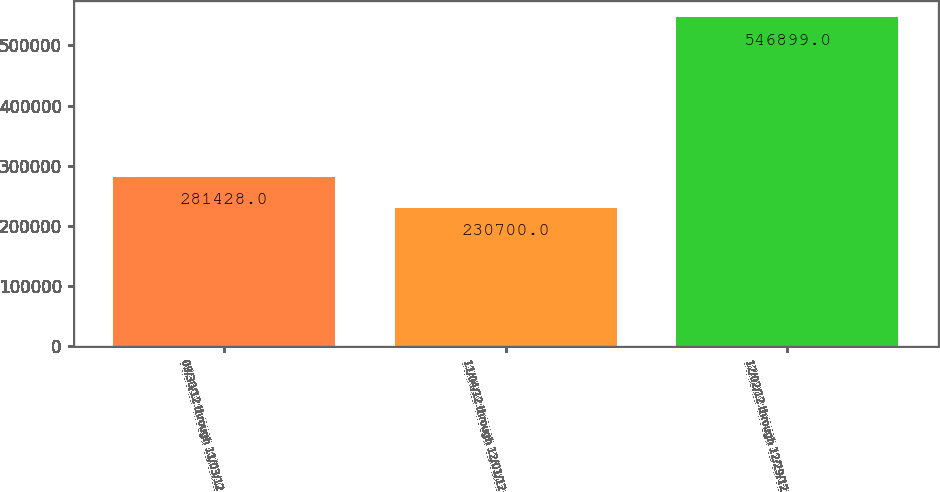Convert chart. <chart><loc_0><loc_0><loc_500><loc_500><bar_chart><fcel>09/30/12 through 11/03/12<fcel>11/04/12 through 12/01/12<fcel>12/02/12 through 12/29/12<nl><fcel>281428<fcel>230700<fcel>546899<nl></chart> 